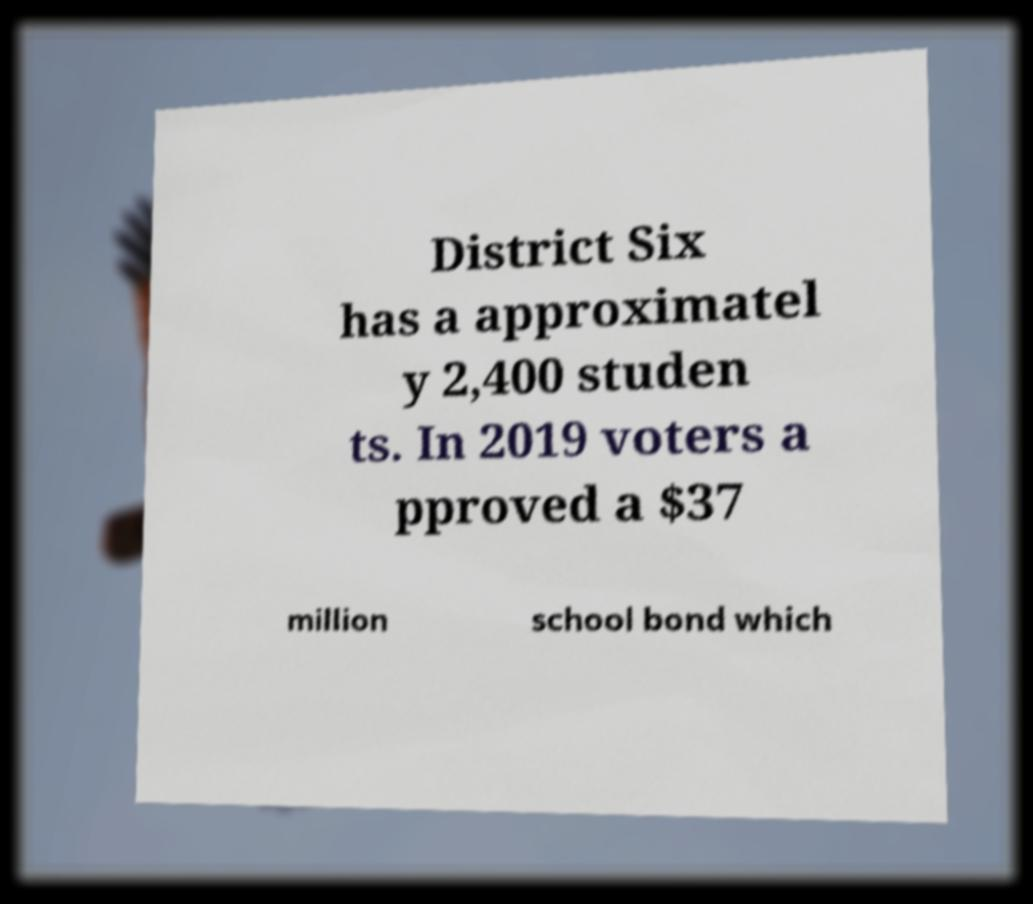What messages or text are displayed in this image? I need them in a readable, typed format. District Six has a approximatel y 2,400 studen ts. In 2019 voters a pproved a $37 million school bond which 